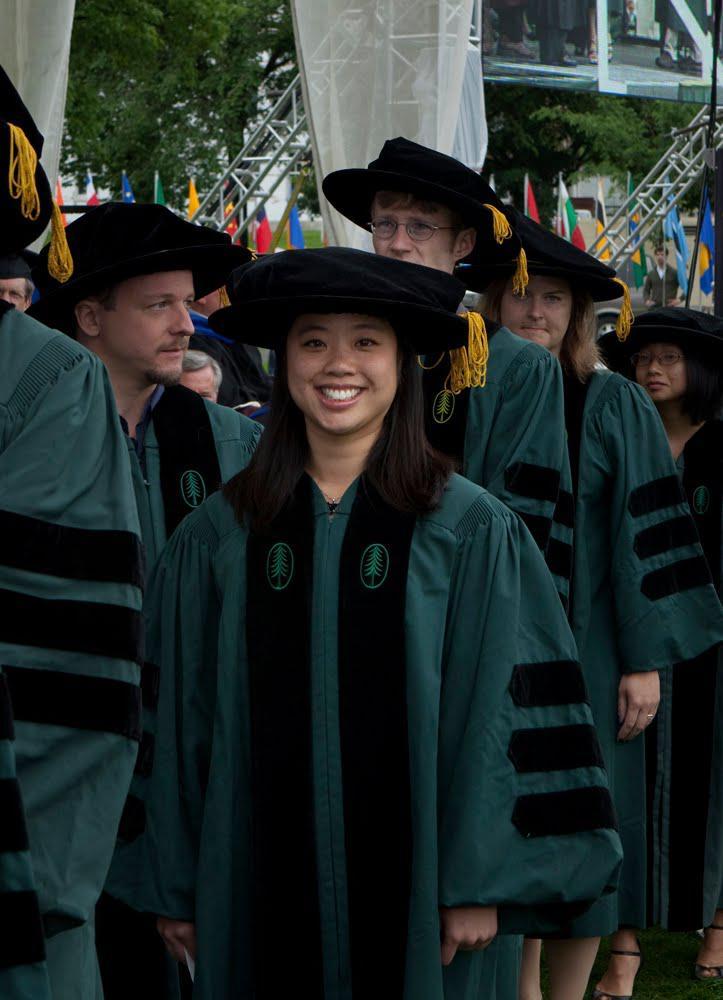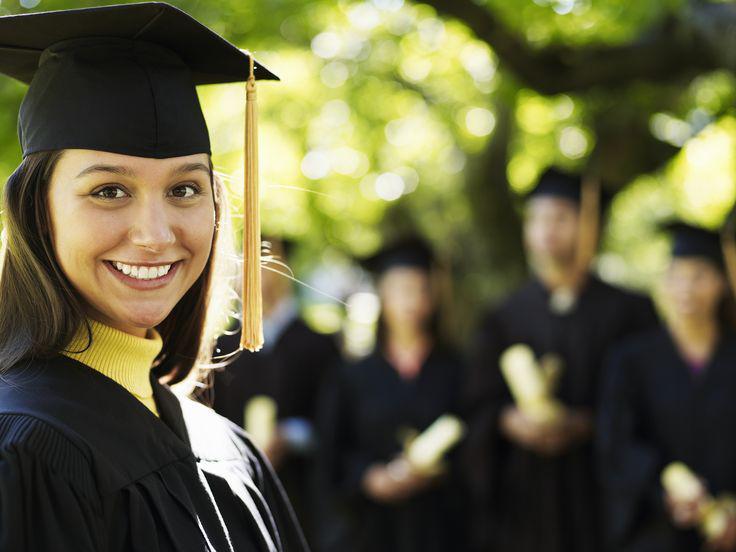The first image is the image on the left, the second image is the image on the right. Examine the images to the left and right. Is the description "Two people, a woman and a man, are wearing graduation attire in the image on the right." accurate? Answer yes or no. No. The first image is the image on the left, the second image is the image on the right. Analyze the images presented: Is the assertion "An image shows two side-by-side camera-facing graduates who together hold up a single object in front of them." valid? Answer yes or no. No. 